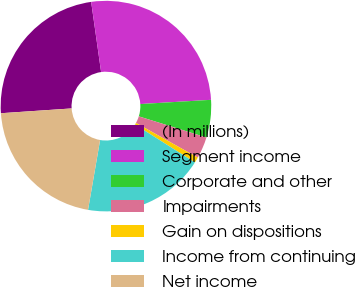Convert chart to OTSL. <chart><loc_0><loc_0><loc_500><loc_500><pie_chart><fcel>(In millions)<fcel>Segment income<fcel>Corporate and other<fcel>Impairments<fcel>Gain on dispositions<fcel>Income from continuing<fcel>Net income<nl><fcel>23.83%<fcel>26.29%<fcel>5.77%<fcel>3.31%<fcel>0.85%<fcel>18.74%<fcel>21.2%<nl></chart> 